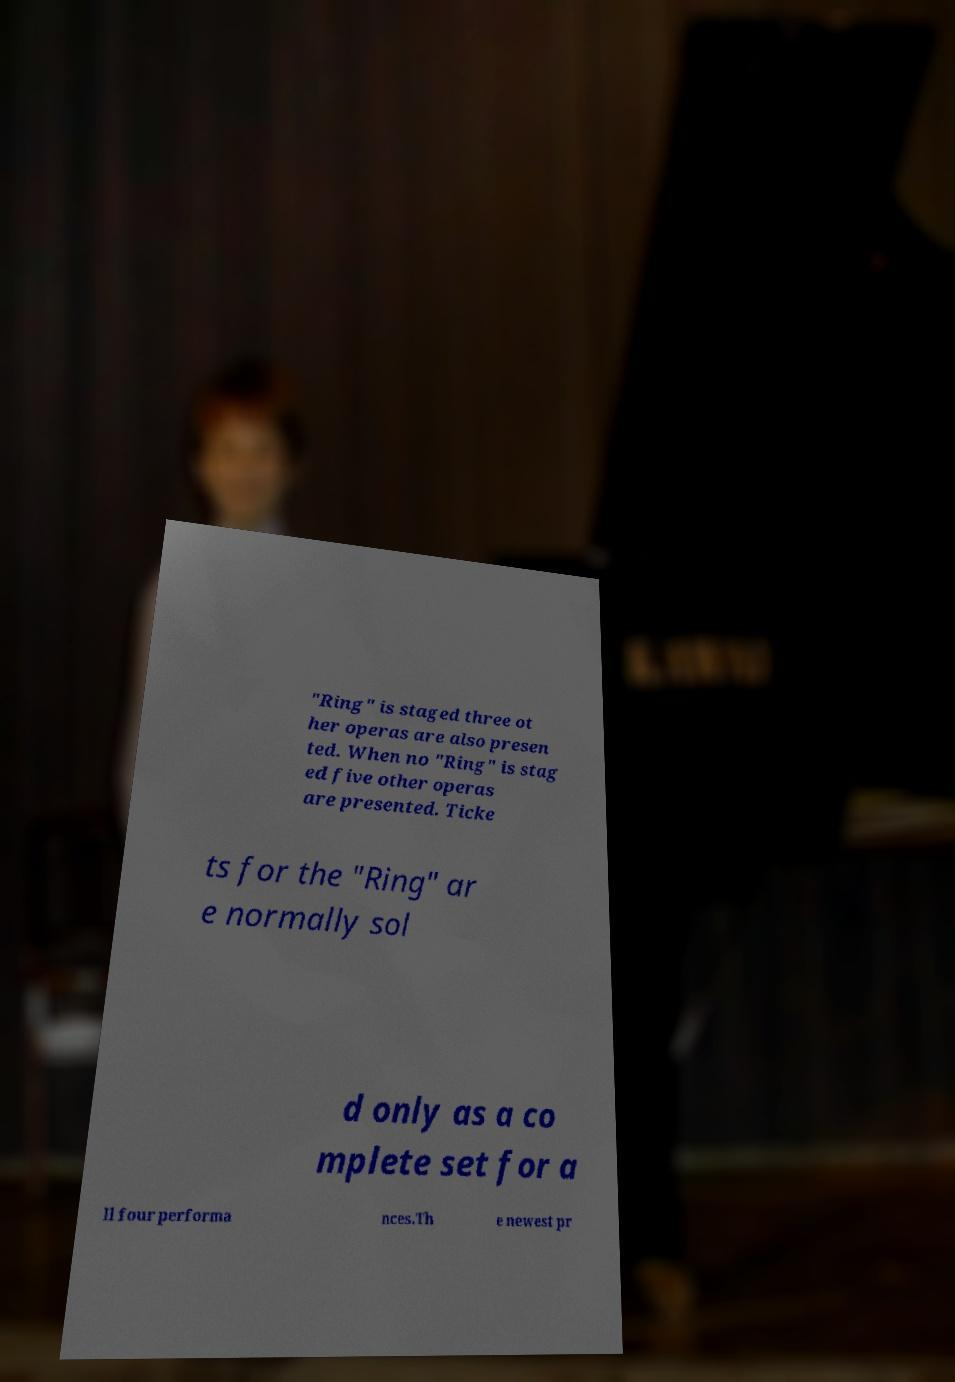Please identify and transcribe the text found in this image. "Ring" is staged three ot her operas are also presen ted. When no "Ring" is stag ed five other operas are presented. Ticke ts for the "Ring" ar e normally sol d only as a co mplete set for a ll four performa nces.Th e newest pr 